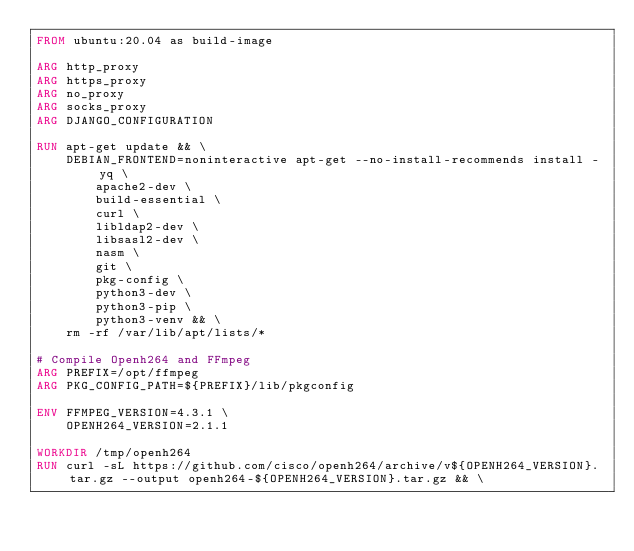Convert code to text. <code><loc_0><loc_0><loc_500><loc_500><_Dockerfile_>FROM ubuntu:20.04 as build-image

ARG http_proxy
ARG https_proxy
ARG no_proxy
ARG socks_proxy
ARG DJANGO_CONFIGURATION

RUN apt-get update && \
    DEBIAN_FRONTEND=noninteractive apt-get --no-install-recommends install -yq \
        apache2-dev \
        build-essential \
        curl \
        libldap2-dev \
        libsasl2-dev \
        nasm \
        git \
        pkg-config \
        python3-dev \
        python3-pip \
        python3-venv && \
    rm -rf /var/lib/apt/lists/*

# Compile Openh264 and FFmpeg
ARG PREFIX=/opt/ffmpeg
ARG PKG_CONFIG_PATH=${PREFIX}/lib/pkgconfig

ENV FFMPEG_VERSION=4.3.1 \
    OPENH264_VERSION=2.1.1

WORKDIR /tmp/openh264
RUN curl -sL https://github.com/cisco/openh264/archive/v${OPENH264_VERSION}.tar.gz --output openh264-${OPENH264_VERSION}.tar.gz && \</code> 